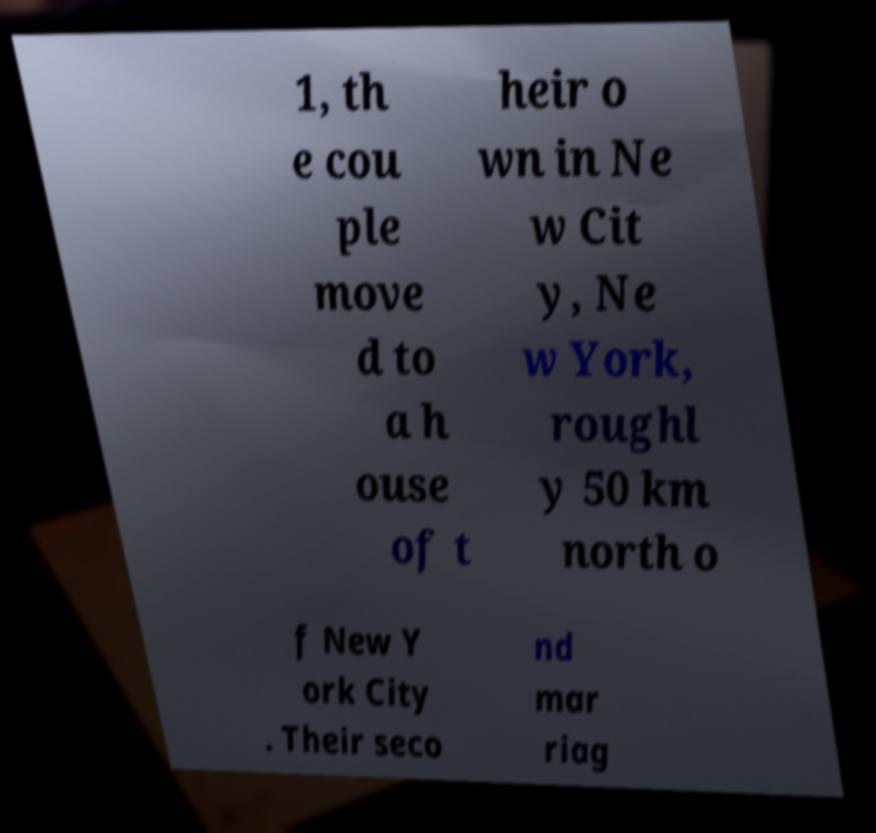There's text embedded in this image that I need extracted. Can you transcribe it verbatim? 1, th e cou ple move d to a h ouse of t heir o wn in Ne w Cit y, Ne w York, roughl y 50 km north o f New Y ork City . Their seco nd mar riag 